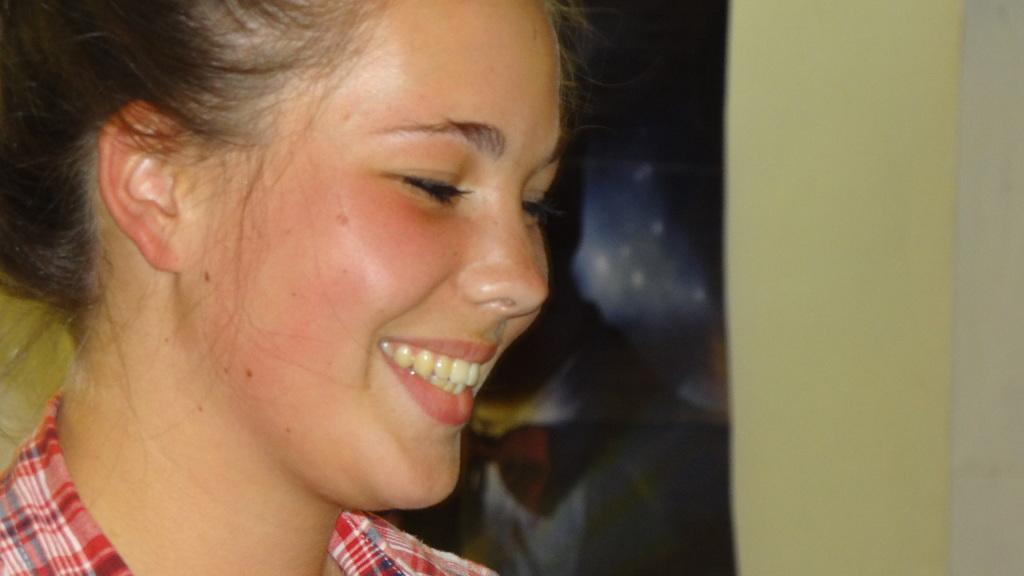How would you summarize this image in a sentence or two? In this picture we can see a girl and she is smiling. 